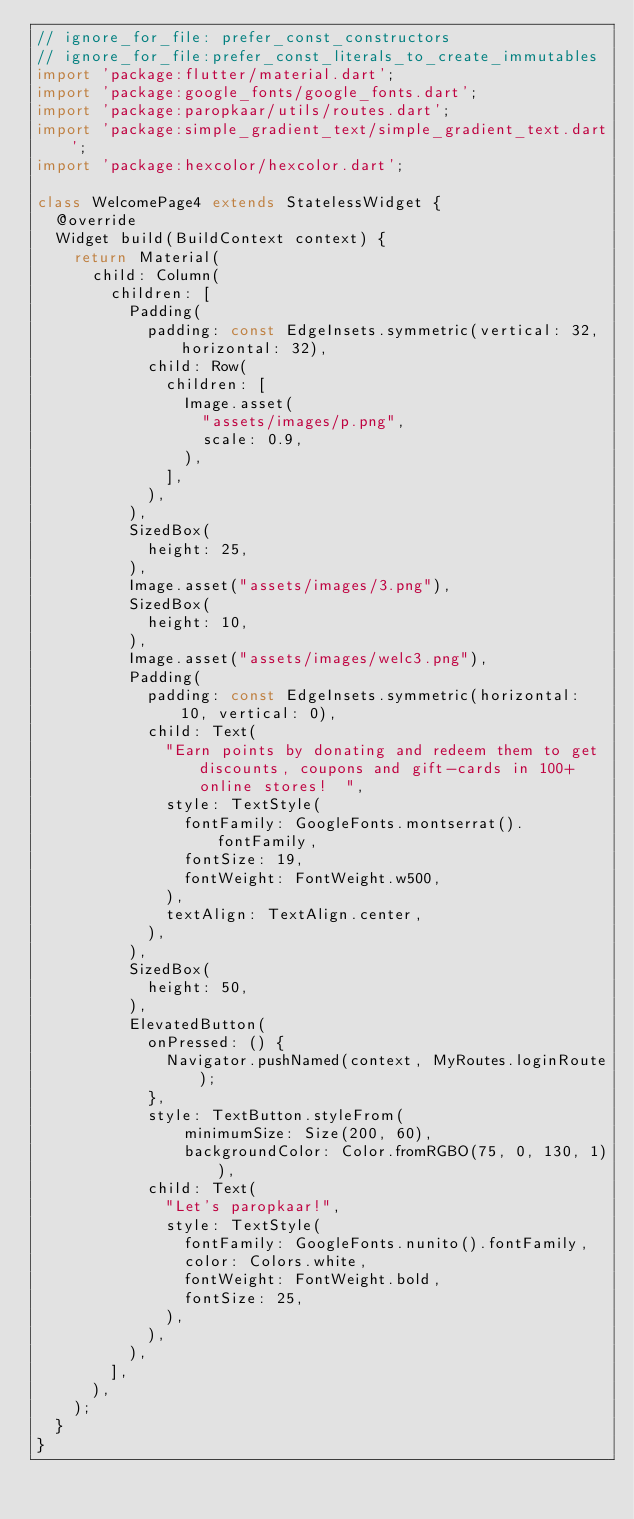Convert code to text. <code><loc_0><loc_0><loc_500><loc_500><_Dart_>// ignore_for_file: prefer_const_constructors
// ignore_for_file:prefer_const_literals_to_create_immutables
import 'package:flutter/material.dart';
import 'package:google_fonts/google_fonts.dart';
import 'package:paropkaar/utils/routes.dart';
import 'package:simple_gradient_text/simple_gradient_text.dart';
import 'package:hexcolor/hexcolor.dart';

class WelcomePage4 extends StatelessWidget {
  @override
  Widget build(BuildContext context) {
    return Material(
      child: Column(
        children: [
          Padding(
            padding: const EdgeInsets.symmetric(vertical: 32, horizontal: 32),
            child: Row(
              children: [
                Image.asset(
                  "assets/images/p.png",
                  scale: 0.9,
                ),
              ],
            ),
          ),
          SizedBox(
            height: 25,
          ),
          Image.asset("assets/images/3.png"),
          SizedBox(
            height: 10,
          ),
          Image.asset("assets/images/welc3.png"),
          Padding(
            padding: const EdgeInsets.symmetric(horizontal: 10, vertical: 0),
            child: Text(
              "Earn points by donating and redeem them to get discounts, coupons and gift-cards in 100+ online stores!  ",
              style: TextStyle(
                fontFamily: GoogleFonts.montserrat().fontFamily,
                fontSize: 19,
                fontWeight: FontWeight.w500,
              ),
              textAlign: TextAlign.center,
            ),
          ),
          SizedBox(
            height: 50,
          ),
          ElevatedButton(
            onPressed: () {
              Navigator.pushNamed(context, MyRoutes.loginRoute);
            },
            style: TextButton.styleFrom(
                minimumSize: Size(200, 60),
                backgroundColor: Color.fromRGBO(75, 0, 130, 1)),
            child: Text(
              "Let's paropkaar!",
              style: TextStyle(
                fontFamily: GoogleFonts.nunito().fontFamily,
                color: Colors.white,
                fontWeight: FontWeight.bold,
                fontSize: 25,
              ),
            ),
          ),
        ],
      ),
    );
  }
}
</code> 